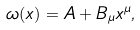Convert formula to latex. <formula><loc_0><loc_0><loc_500><loc_500>\omega ( x ) = A + B _ { \mu } x ^ { \mu } ,</formula> 